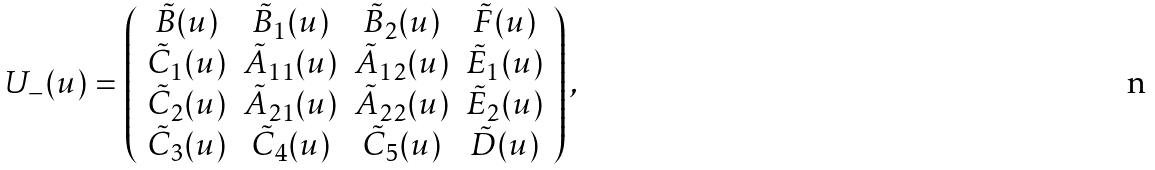<formula> <loc_0><loc_0><loc_500><loc_500>U _ { - } ( u ) = \left ( \begin{array} { c c c c } \tilde { B } ( u ) & \tilde { B } _ { 1 } ( u ) & \tilde { B } _ { 2 } ( u ) & \tilde { F } ( u ) \\ \tilde { C } _ { 1 } ( u ) & \tilde { A } _ { 1 1 } ( u ) & \tilde { A } _ { 1 2 } ( u ) & \tilde { E } _ { 1 } ( u ) \\ \tilde { C } _ { 2 } ( u ) & \tilde { A } _ { 2 1 } ( u ) & \tilde { A } _ { 2 2 } ( u ) & \tilde { E } _ { 2 } ( u ) \\ \tilde { C } _ { 3 } ( u ) & \tilde { C } _ { 4 } ( u ) & \tilde { C } _ { 5 } ( u ) & \tilde { D } ( u ) \end{array} \right ) ,</formula> 